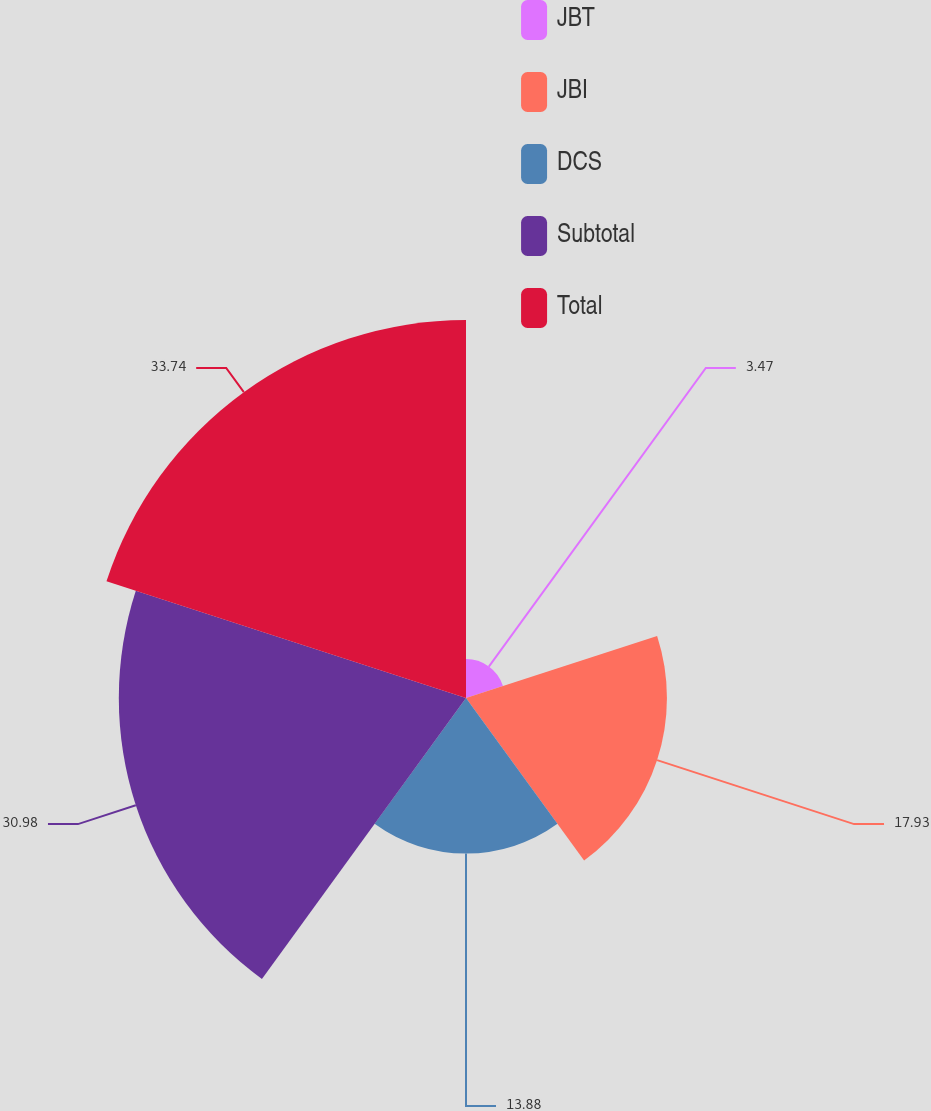Convert chart to OTSL. <chart><loc_0><loc_0><loc_500><loc_500><pie_chart><fcel>JBT<fcel>JBI<fcel>DCS<fcel>Subtotal<fcel>Total<nl><fcel>3.47%<fcel>17.93%<fcel>13.88%<fcel>30.98%<fcel>33.73%<nl></chart> 